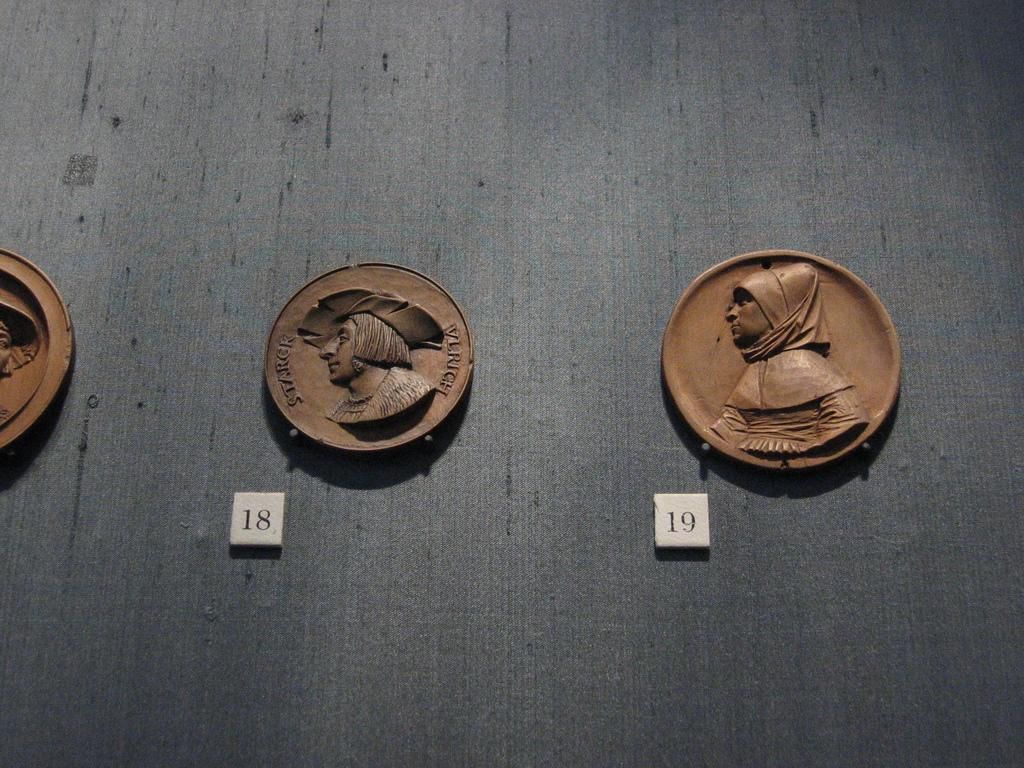<image>
Share a concise interpretation of the image provided. old terrocotta plates of pilgrims auction numbers 18 and 19 